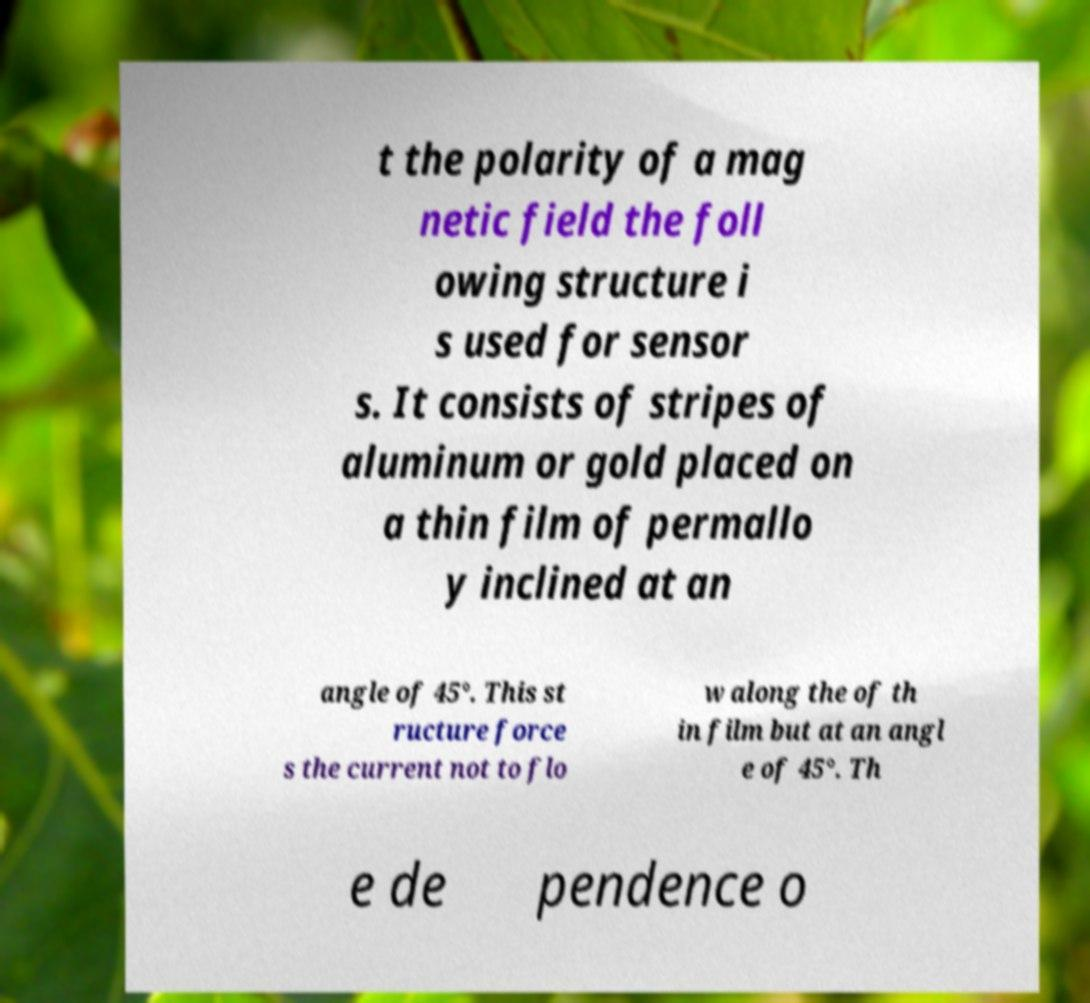Can you accurately transcribe the text from the provided image for me? t the polarity of a mag netic field the foll owing structure i s used for sensor s. It consists of stripes of aluminum or gold placed on a thin film of permallo y inclined at an angle of 45°. This st ructure force s the current not to flo w along the of th in film but at an angl e of 45°. Th e de pendence o 